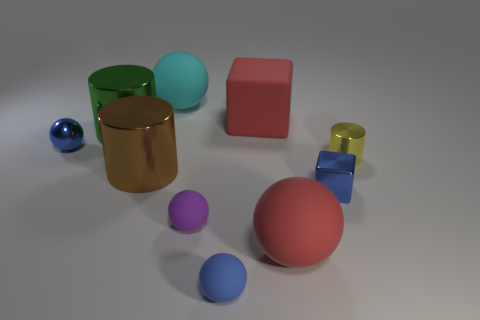Subtract all cyan spheres. How many spheres are left? 4 Subtract all small shiny spheres. How many spheres are left? 4 Subtract 2 balls. How many balls are left? 3 Subtract all yellow balls. Subtract all cyan cylinders. How many balls are left? 5 Subtract all cubes. How many objects are left? 8 Subtract all tiny purple matte spheres. Subtract all big matte spheres. How many objects are left? 7 Add 3 metallic objects. How many metallic objects are left? 8 Add 3 big matte things. How many big matte things exist? 6 Subtract 0 purple cylinders. How many objects are left? 10 